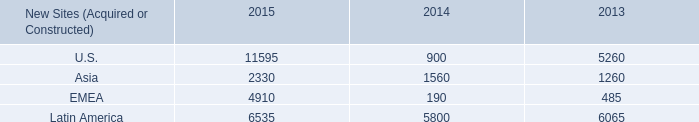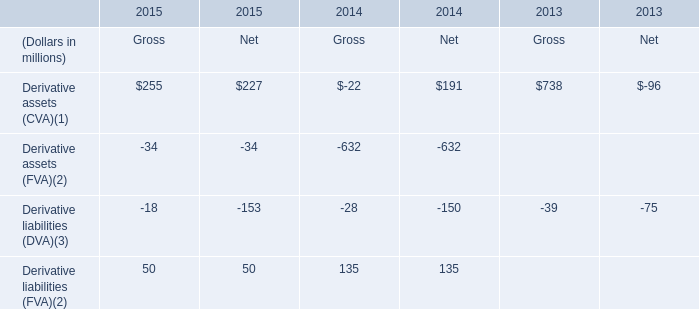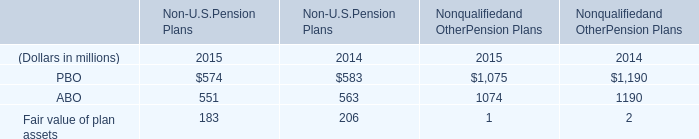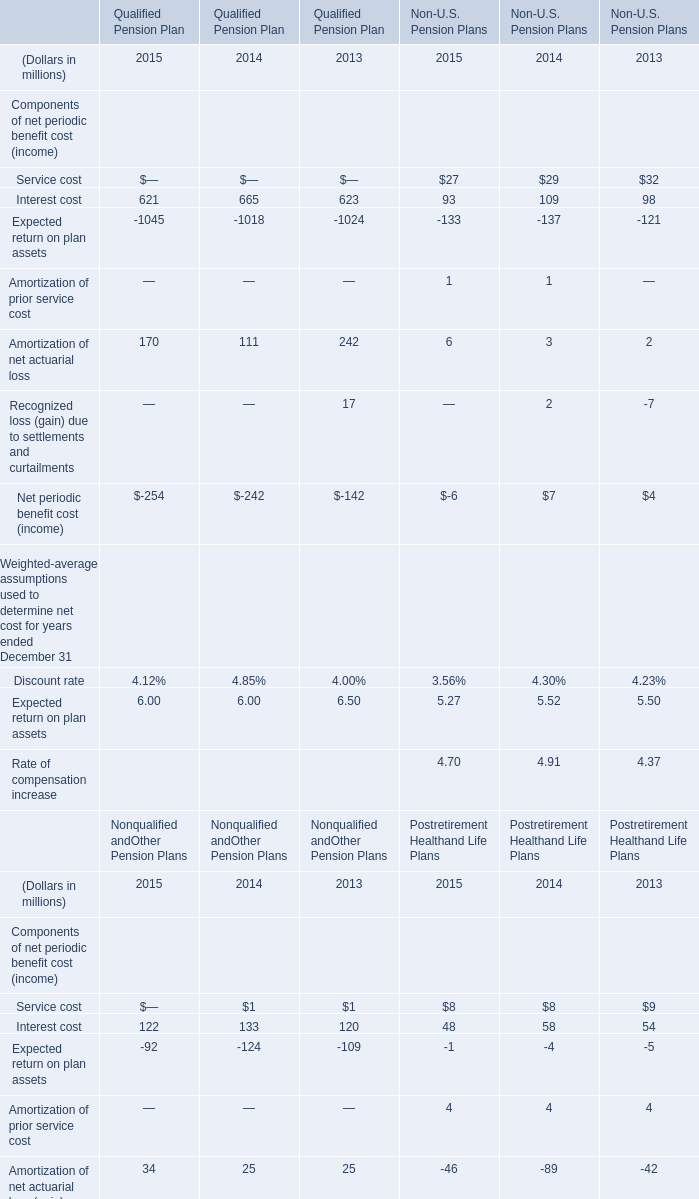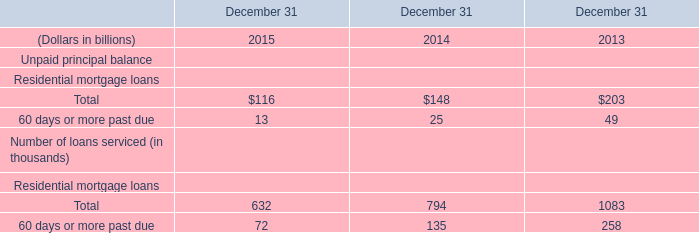What's the total amount of the Components of net periodic benefit cost (income) in the years where Net periodic benefit cost (income) is greater than 0? (in million) 
Computations: ((((((((((((109 + 29) - 137) + 1) + 3) + 2) + 7) + 32) + 98) - 121) + 2) - 7) + 4)
Answer: 22.0. 